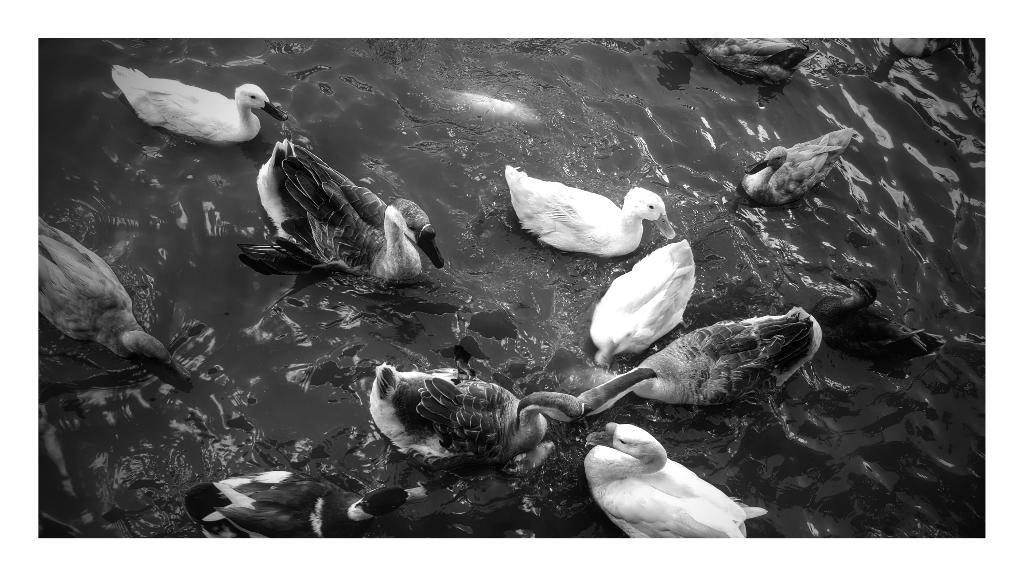What is the color scheme of the image? The image is black and white. What animals can be seen in the image? There are ducks in the water in the image. What type of wool can be seen on the ducks in the image? There is no wool present on the ducks in the image; they are in the water. 